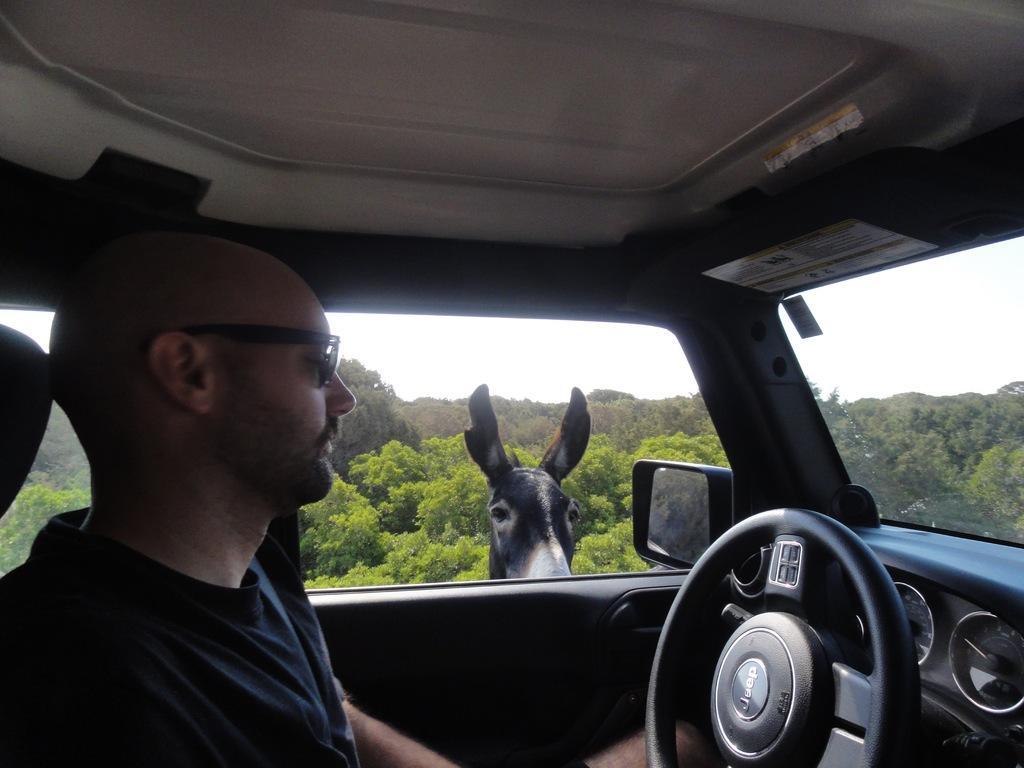How would you summarize this image in a sentence or two? In this image, a man is inside the car. On right side, we can see steering, rado meter, glass, side window. In the middle, there is an animal viewing. Background, we can so many trees and sky. On left side , there is a seat. 